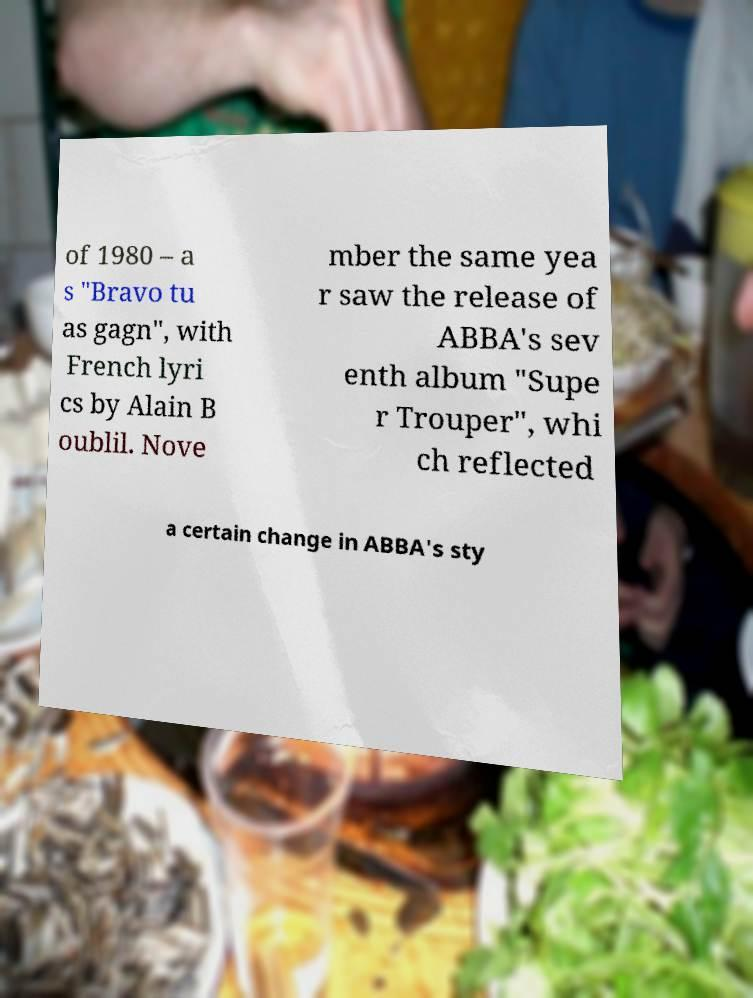Can you accurately transcribe the text from the provided image for me? of 1980 – a s "Bravo tu as gagn", with French lyri cs by Alain B oublil. Nove mber the same yea r saw the release of ABBA's sev enth album "Supe r Trouper", whi ch reflected a certain change in ABBA's sty 